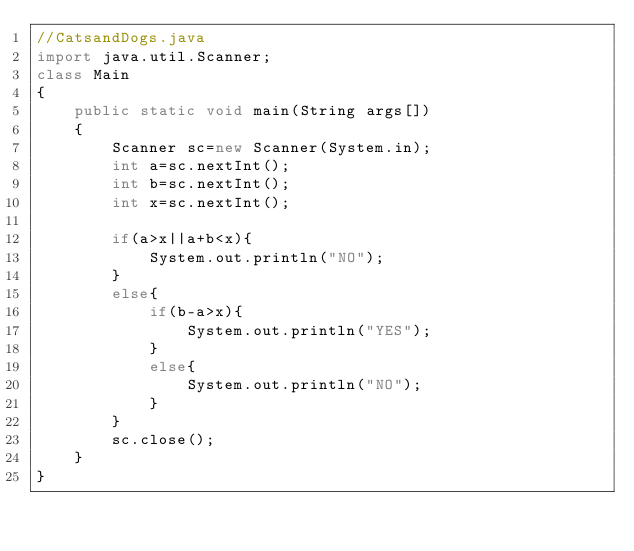Convert code to text. <code><loc_0><loc_0><loc_500><loc_500><_Java_>//CatsandDogs.java
import java.util.Scanner;
class Main
{
	public static void main(String args[])
	{
		Scanner sc=new Scanner(System.in);
		int a=sc.nextInt();
        int b=sc.nextInt();
        int x=sc.nextInt();

        if(a>x||a+b<x){
            System.out.println("NO");
        }
        else{
            if(b-a>x){
                System.out.println("YES");
            }
            else{
                System.out.println("NO");
            }
        }
        sc.close();
    }
}	</code> 